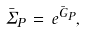<formula> <loc_0><loc_0><loc_500><loc_500>\bar { \Sigma } _ { P } \, = \, e ^ { \bar { G } _ { P } } ,</formula> 